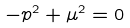<formula> <loc_0><loc_0><loc_500><loc_500>- p ^ { 2 } + \mu ^ { 2 } = 0</formula> 